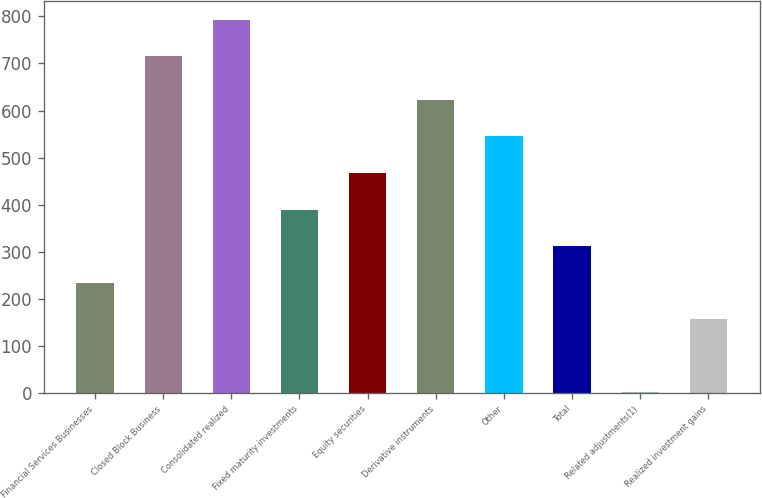Convert chart to OTSL. <chart><loc_0><loc_0><loc_500><loc_500><bar_chart><fcel>Financial Services Businesses<fcel>Closed Block Business<fcel>Consolidated realized<fcel>Fixed maturity investments<fcel>Equity securities<fcel>Derivative instruments<fcel>Other<fcel>Total<fcel>Related adjustments(1)<fcel>Realized investment gains<nl><fcel>234.1<fcel>715<fcel>792.7<fcel>389.5<fcel>467.2<fcel>622.6<fcel>544.9<fcel>311.8<fcel>1<fcel>156.4<nl></chart> 